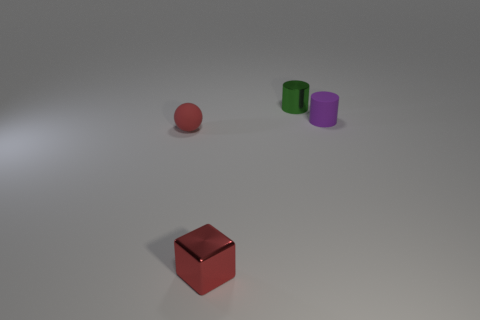Are the tiny cube and the small cylinder left of the purple cylinder made of the same material?
Make the answer very short. Yes. How many shiny things are tiny green things or tiny purple things?
Offer a very short reply. 1. There is a shiny thing in front of the tiny rubber cylinder; what is its size?
Make the answer very short. Small. There is a object that is made of the same material as the block; what size is it?
Your response must be concise. Small. What number of rubber cylinders have the same color as the metal block?
Offer a very short reply. 0. Is there a big purple rubber sphere?
Offer a terse response. No. There is a green object; is its shape the same as the shiny thing that is in front of the small rubber cylinder?
Offer a very short reply. No. What color is the matte object that is left of the small shiny thing that is in front of the tiny thing that is on the left side of the metal block?
Offer a terse response. Red. Are there any tiny red cubes to the left of the rubber ball?
Keep it short and to the point. No. There is a matte object that is the same color as the metal block; what is its size?
Your answer should be very brief. Small. 